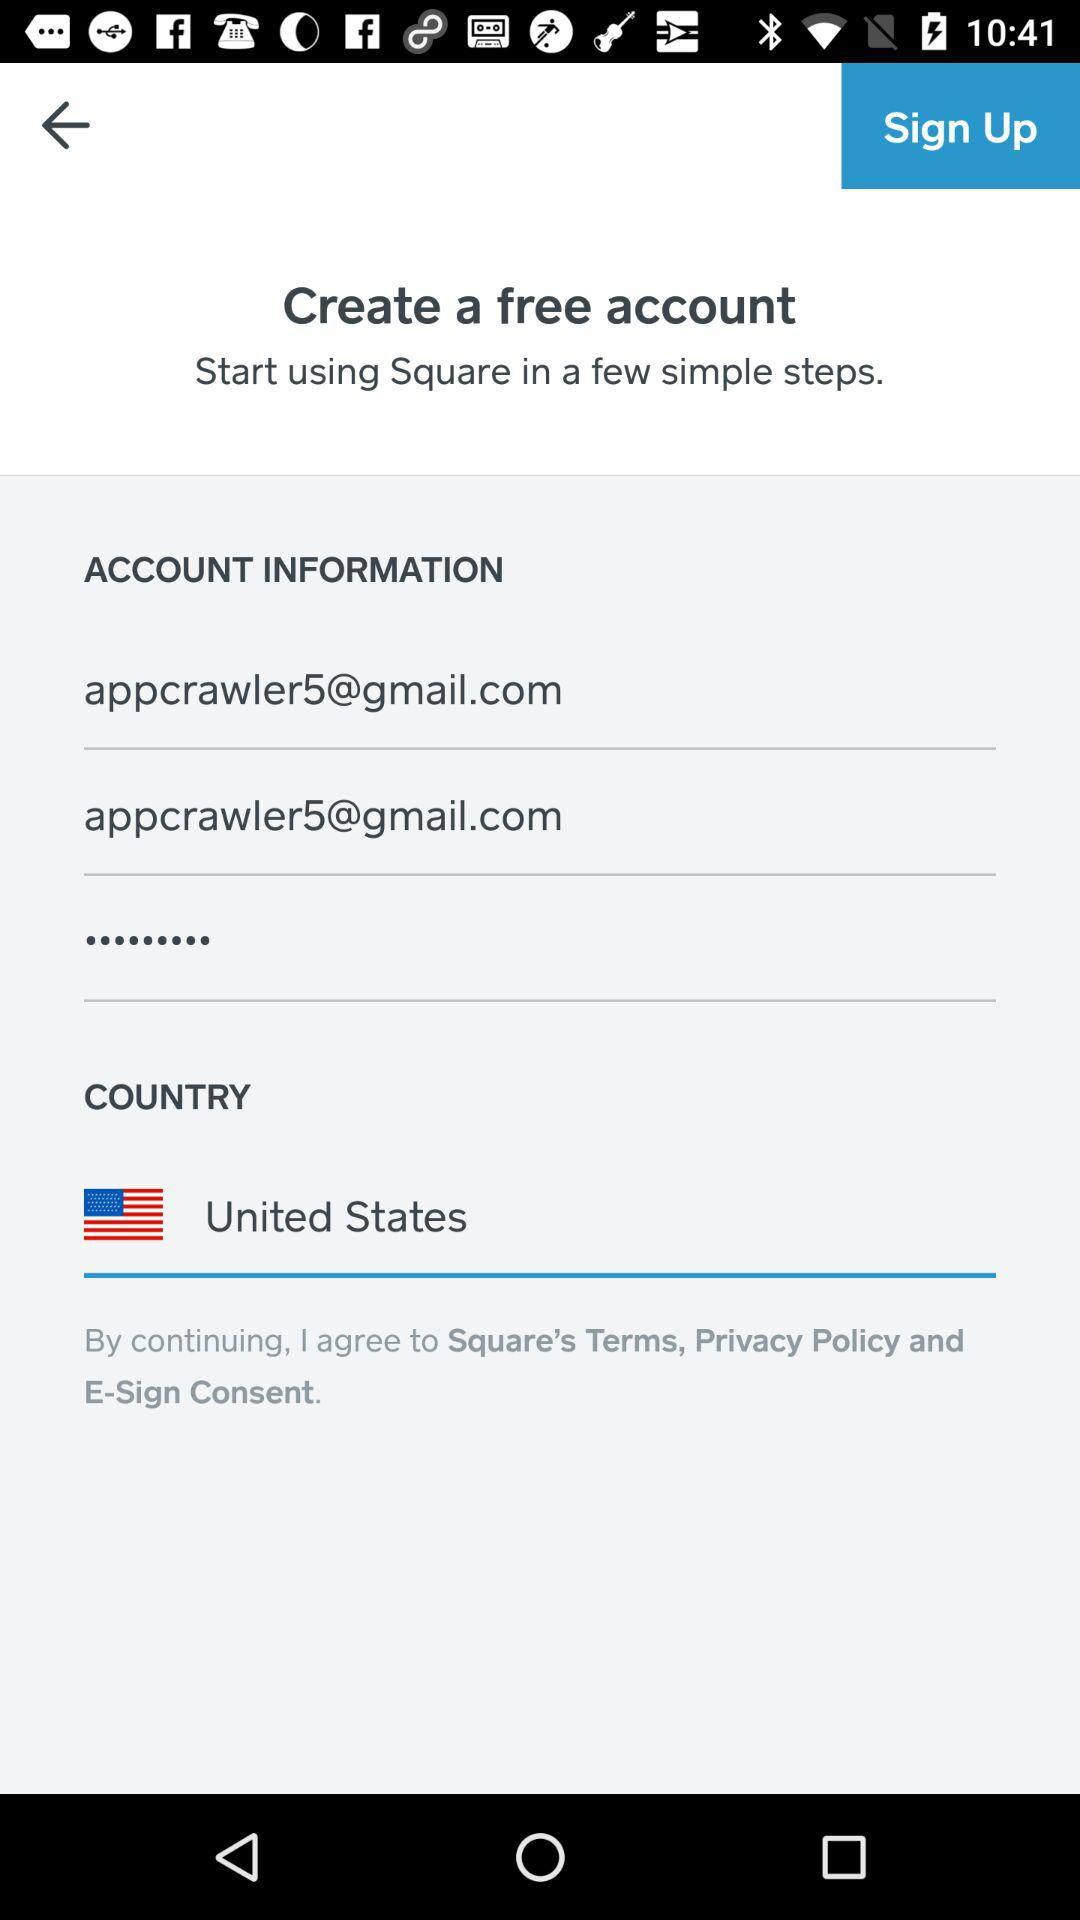Is the account free or paid? The account is free. 